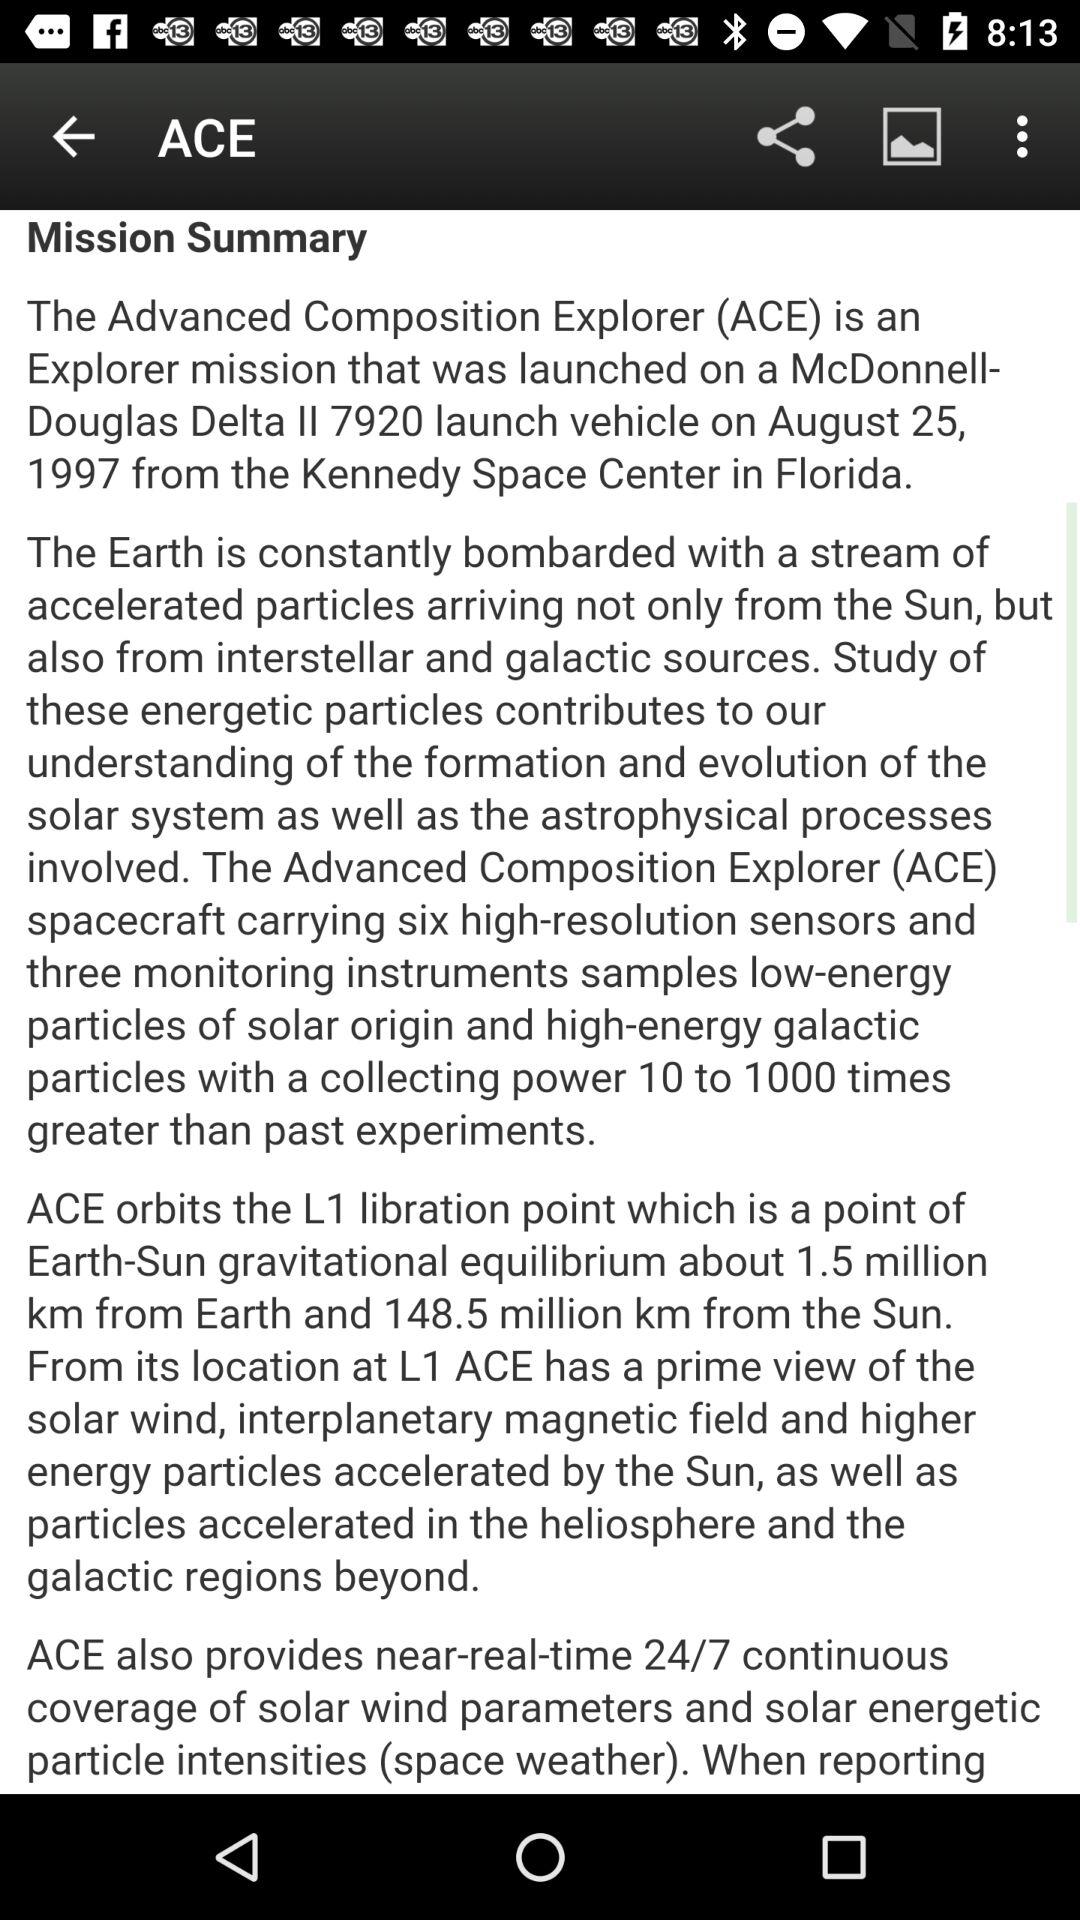What is the full form of ACE? ACE stands for Advanced Composition Explorer. 